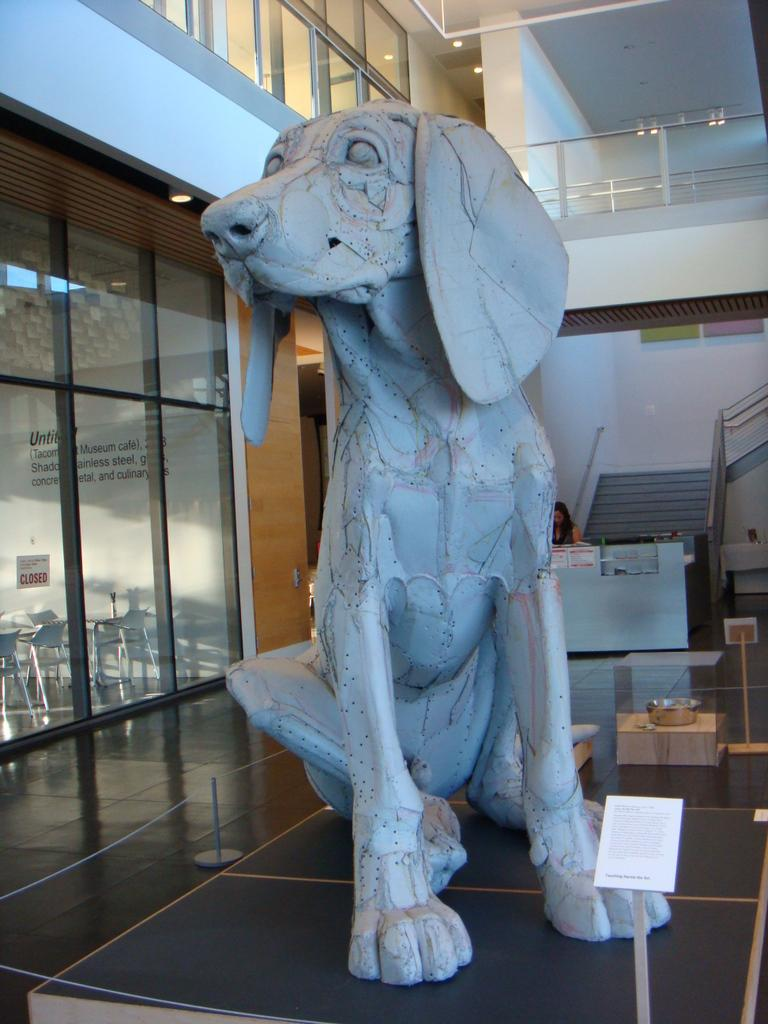What is the main subject in the image? There is a statue in the image. Where is the statue located? The statue is on a platform. What can be seen in the background of the image? There is a wall and rods in the background of the image. Are there any people visible in the image? Yes, there is a woman in the background of the image. How much soup is the woman holding in the image? There is no soup present in the image, and the woman is not holding anything. 